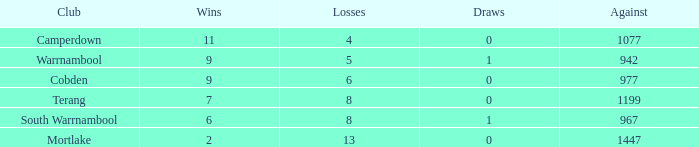How many wins did Cobden have when draws were more than 0? 0.0. 